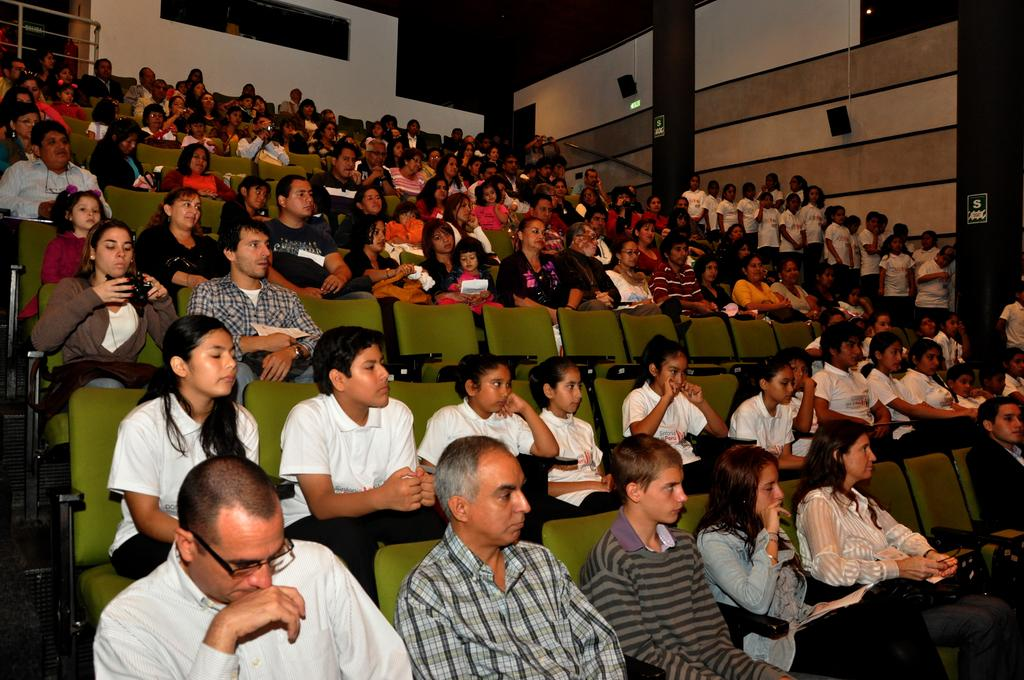What type of seating is visible in the image? People are sitting on green chairs in an auditorium. What are the people at the right side of the image doing? People are standing at the right side of the image. What color are the t-shirts worn by the standing people? The standing people are wearing white t-shirts. What type of tub is visible in the image? There is no tub present in the image. How does the queen interact with the people in the image? There is no queen present in the image. 